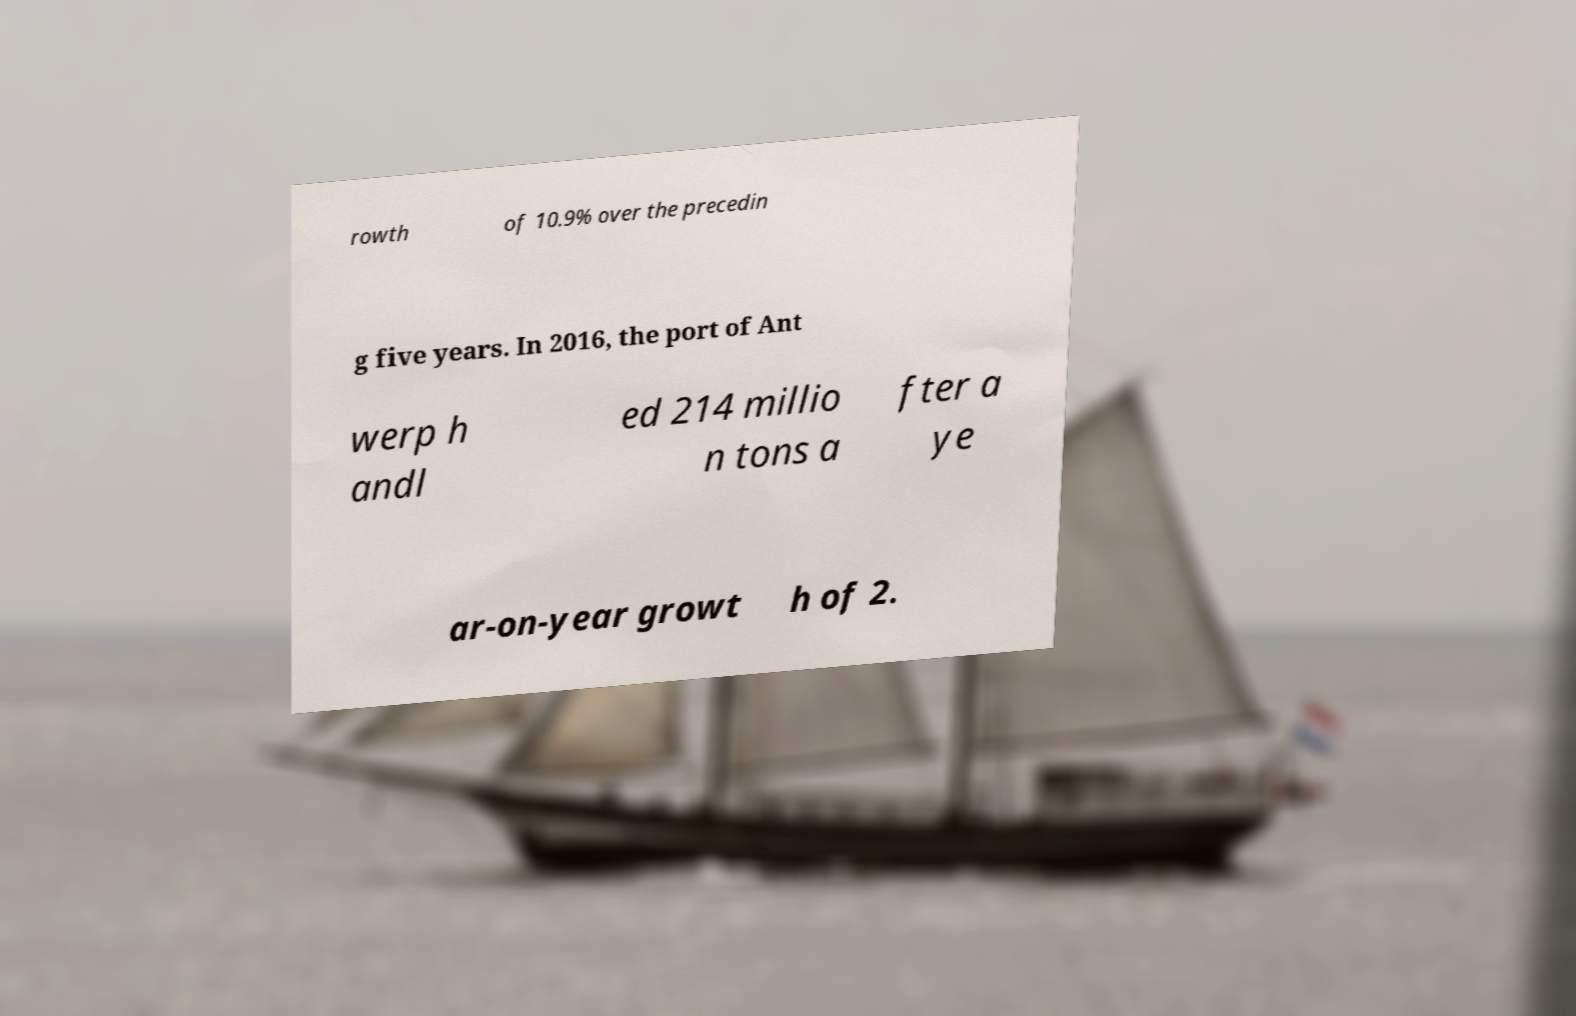Please identify and transcribe the text found in this image. rowth of 10.9% over the precedin g five years. In 2016, the port of Ant werp h andl ed 214 millio n tons a fter a ye ar-on-year growt h of 2. 